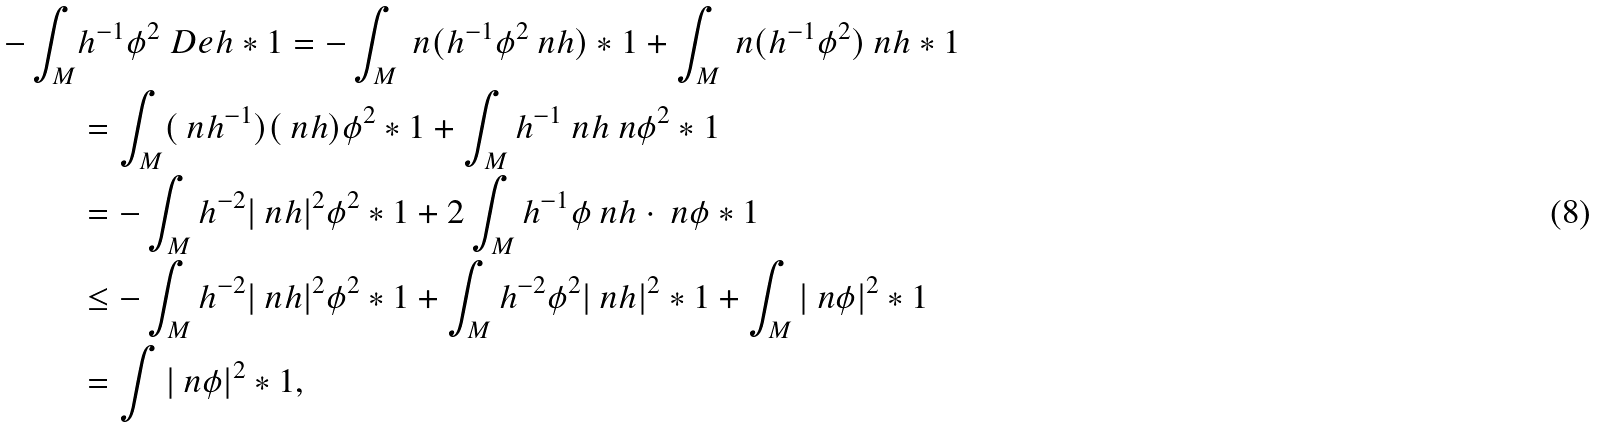<formula> <loc_0><loc_0><loc_500><loc_500>- \int _ { M } & h ^ { - 1 } \phi ^ { 2 } \ D e h * 1 = - \int _ { M } \ n ( h ^ { - 1 } \phi ^ { 2 } \ n h ) * 1 + \int _ { M } \ n ( h ^ { - 1 } \phi ^ { 2 } ) \ n h * 1 \\ & = \int _ { M } ( \ n h ^ { - 1 } ) ( \ n h ) \phi ^ { 2 } * 1 + \int _ { M } h ^ { - 1 } \ n h \ n \phi ^ { 2 } * 1 \\ & = - \int _ { M } h ^ { - 2 } | \ n h | ^ { 2 } \phi ^ { 2 } * 1 + 2 \int _ { M } h ^ { - 1 } \phi \ n h \cdot \ n \phi * 1 \\ & \leq - \int _ { M } h ^ { - 2 } | \ n h | ^ { 2 } \phi ^ { 2 } * 1 + \int _ { M } h ^ { - 2 } \phi ^ { 2 } | \ n h | ^ { 2 } * 1 + \int _ { M } | \ n \phi | ^ { 2 } * 1 \\ & = \int | \ n \phi | ^ { 2 } * 1 ,</formula> 